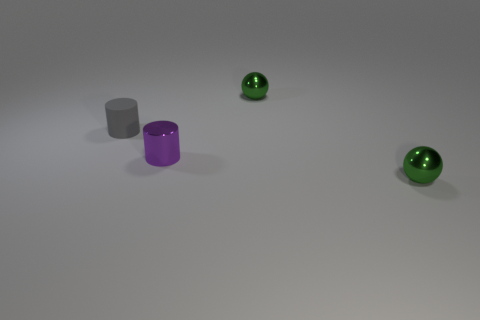How might the lighting affect the appearance of the different surfaces in the image? The lighting creates subtle highlights and shadows that emphasize the textures of the objects. The matte surface of the gray cylinder absorbs light, reducing glare and making its surface appear soft. In contrast, the metallic sheen of the purple cylinder reflects light, creating bright highlights that bring out its curvature. The green spheres have highlighted areas indicating a smooth, reflective surface, which suggests they are quite glossy. 